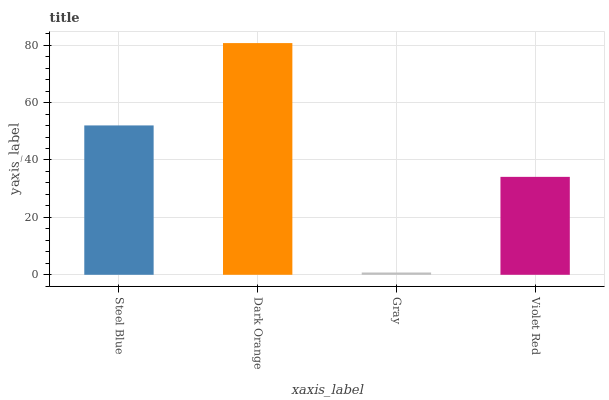Is Gray the minimum?
Answer yes or no. Yes. Is Dark Orange the maximum?
Answer yes or no. Yes. Is Dark Orange the minimum?
Answer yes or no. No. Is Gray the maximum?
Answer yes or no. No. Is Dark Orange greater than Gray?
Answer yes or no. Yes. Is Gray less than Dark Orange?
Answer yes or no. Yes. Is Gray greater than Dark Orange?
Answer yes or no. No. Is Dark Orange less than Gray?
Answer yes or no. No. Is Steel Blue the high median?
Answer yes or no. Yes. Is Violet Red the low median?
Answer yes or no. Yes. Is Gray the high median?
Answer yes or no. No. Is Dark Orange the low median?
Answer yes or no. No. 